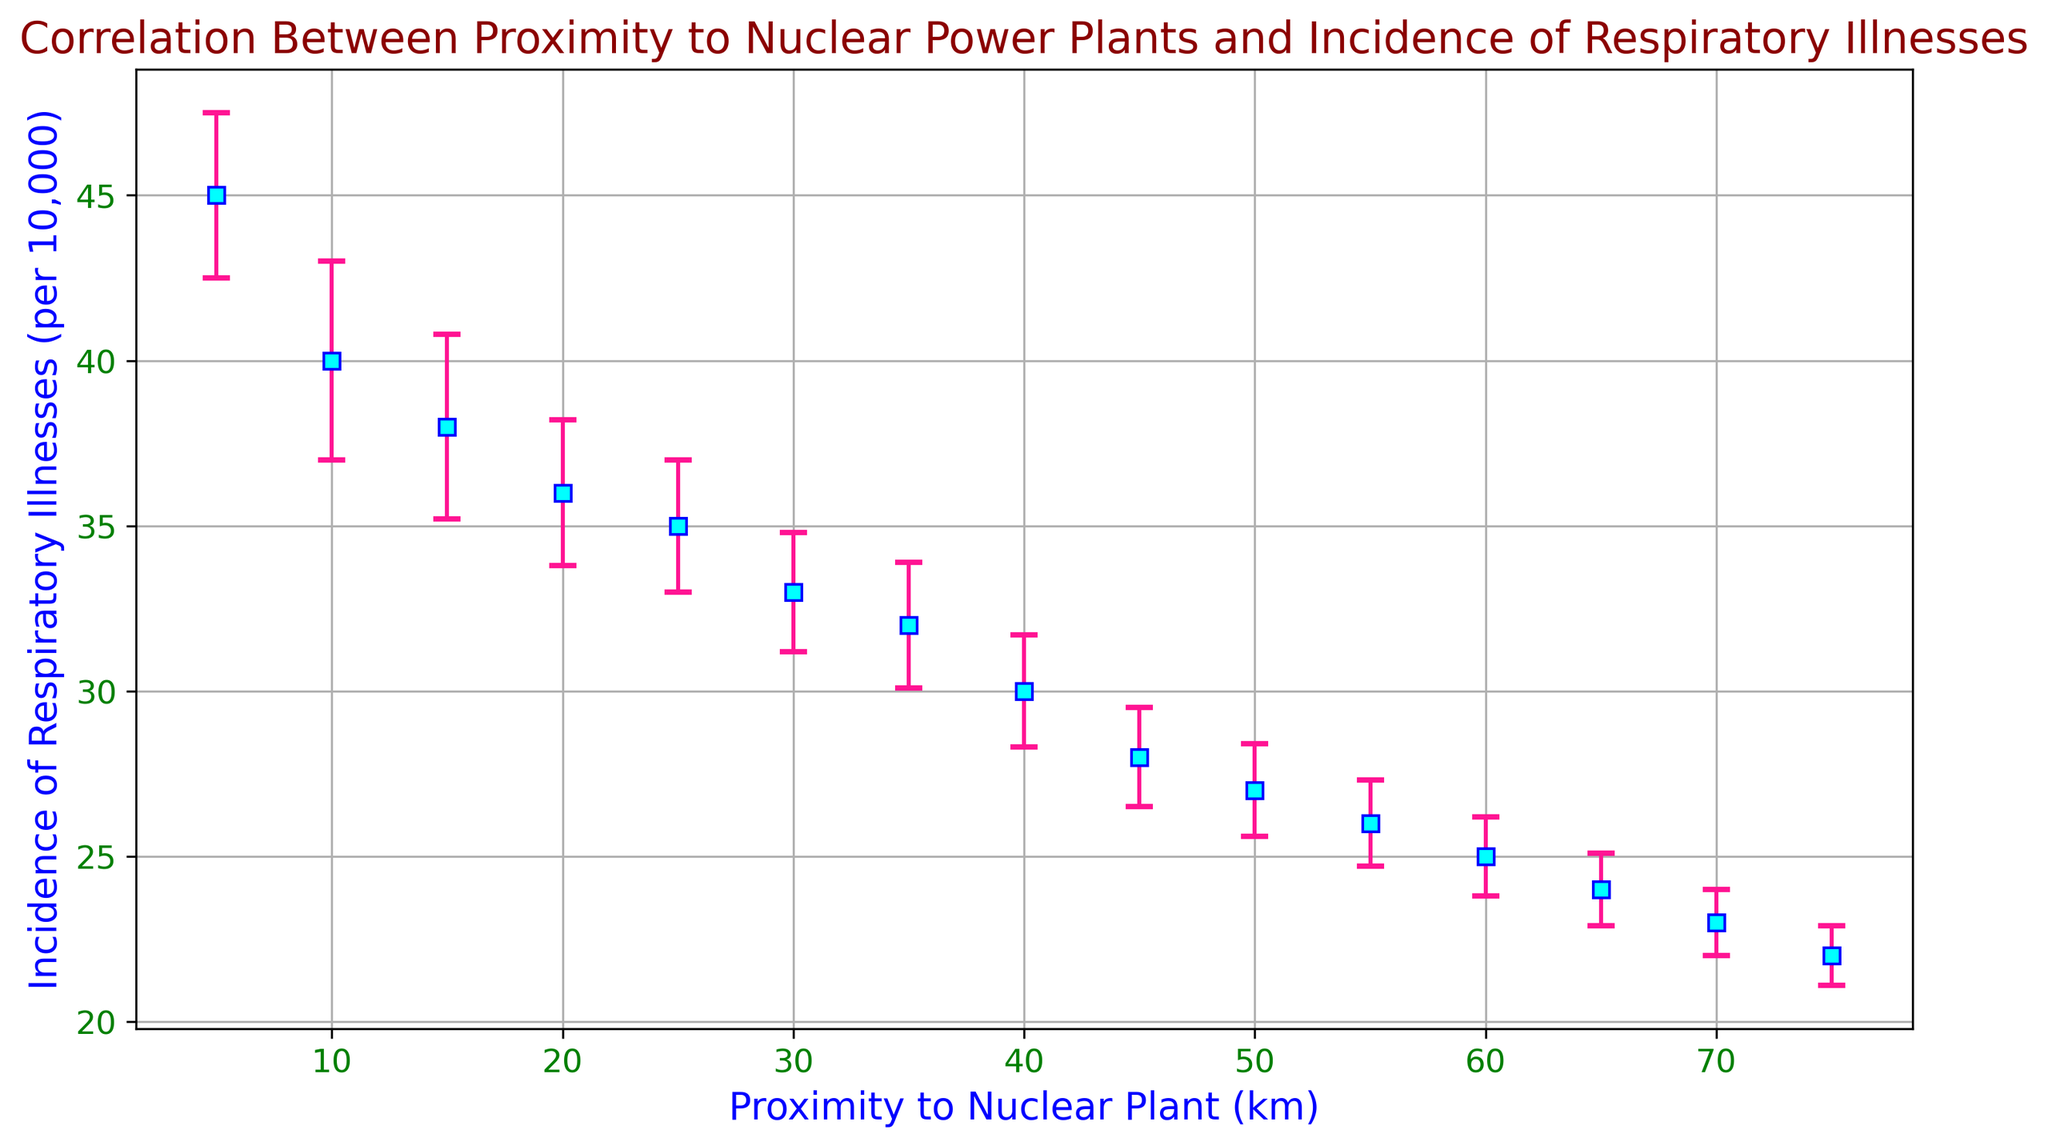What region has the highest incidence of respiratory illnesses per 10,000 people? Just looking at the data points, we can see that Region_A has the highest incidence of respiratory illnesses per 10,000 people.
Answer: Region_A What is the difference in the incidence of respiratory illnesses per 10,000 people between Region_A and Region_O? From the chart, Region_A has an incidence rate of 45, while Region_O has an incidence rate of 22. The difference is calculated as 45 - 22.
Answer: 23 Which region shows the lowest standard deviation in the incidence of respiratory illnesses per 10,000 people? The figure indicates that Region_O has the smallest error bar, which represents the standard deviation.
Answer: Region_O As the proximity to the nuclear plant increases, does the incidence of respiratory illnesses generally increase or decrease? Observing the trend in the figure, as the distance from the plant increases, the incidence of respiratory illnesses tends to decrease.
Answer: Decrease What is the average incidence of respiratory illnesses per 10,000 people for the regions within 20 km proximity to the nuclear plant? The regions within 20 km proximity are Region_A, Region_B, Region_C, and Region_D. Their incidence rates are 45, 40, 38, and 36 respectively. The average is calculated as (45 + 40 + 38 + 36) / 4 = 39.75.
Answer: 39.75 Compare the incidence rates between Region_F and Region_K and state which one is higher. Region_F has an incidence rate of 33, while Region_K has an incidence rate of 26. Region_F has a higher incidence rate.
Answer: Region_F What is the cumulative standard deviation for the first three regions (Region_A, Region_B, and Region_C)? From the chart, the respective standard deviations are 2.5, 3.0, and 2.8. The cumulative standard deviation is 2.5 + 3.0 + 2.8.
Answer: 8.3 Identify the proximity range where the incidence of respiratory illnesses per 10,000 people first falls below 30. Observing the incidence rates in the figure, the incidence rate falls below 30 for the first time in Region_I which is 45 km from the nuclear plant.
Answer: 45 km What is the percentage change in the incidence of respiratory illnesses from Region_D to Region_M? Region_D has an incidence of 36 and Region_M has an incidence of 24. The percentage change is calculated as ((24 - 36) / 36) * 100 = -33.33%.
Answer: -33.33% Among regions with a proximity of less than 30 km, which one has the highest standard deviation in the incidence of respiratory illnesses? The regions with a proximity of less than 30 km are Region_A through Region_E. By comparing their standard deviations (2.5, 3.0, 2.8, 2.2, 2.0), Region_B has the highest standard deviation of 3.0.
Answer: Region_B 